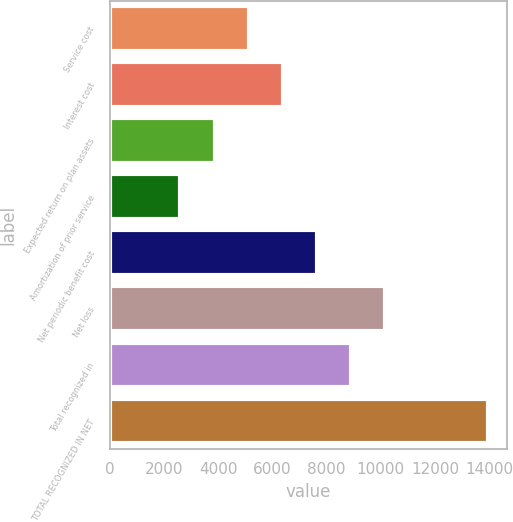<chart> <loc_0><loc_0><loc_500><loc_500><bar_chart><fcel>Service cost<fcel>Interest cost<fcel>Expected return on plan assets<fcel>Amortization of prior service<fcel>Net periodic benefit cost<fcel>Net loss<fcel>Total recognized in<fcel>TOTAL RECOGNIZED IN NET<nl><fcel>5124.1<fcel>6384.8<fcel>3863.4<fcel>2602.7<fcel>7645.5<fcel>10166.9<fcel>8906.2<fcel>13949<nl></chart> 